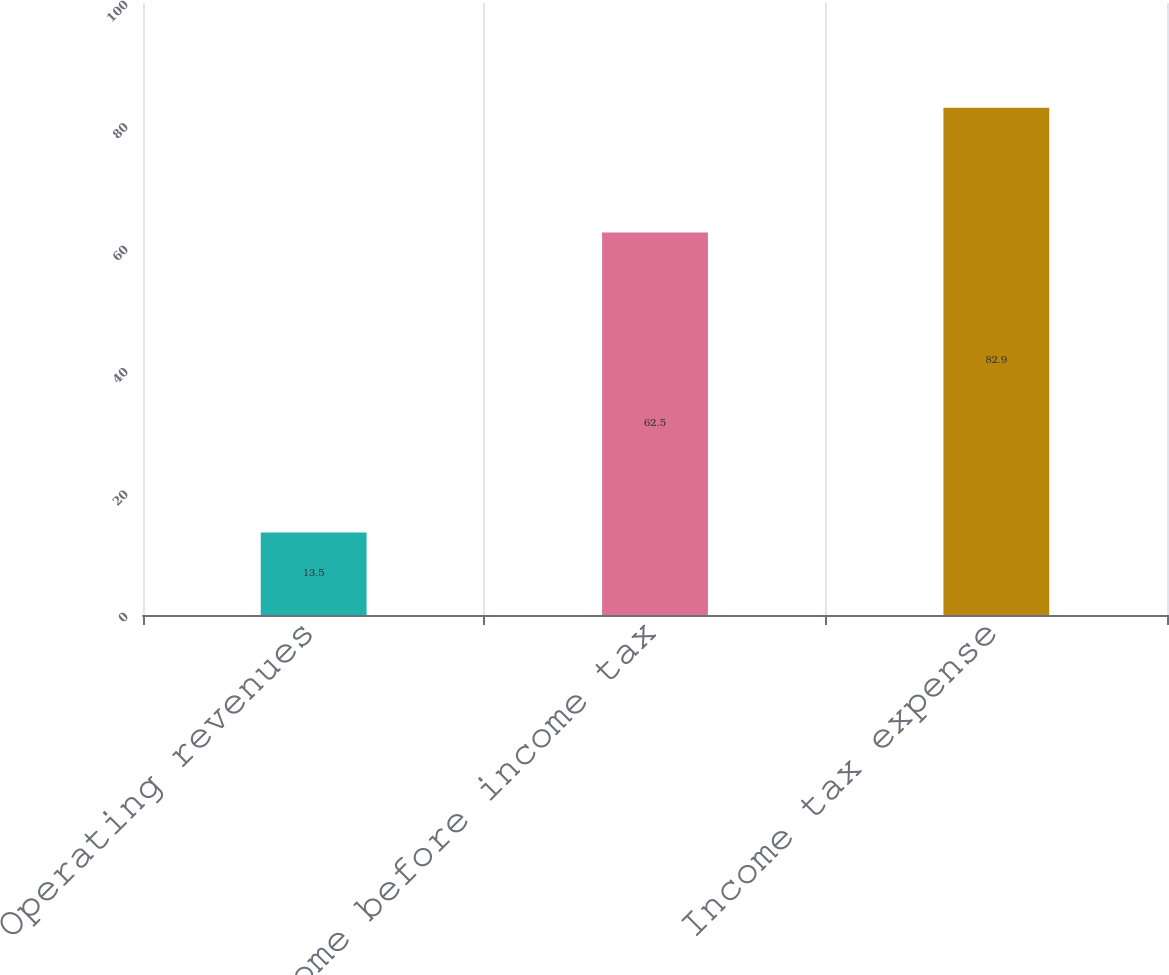Convert chart to OTSL. <chart><loc_0><loc_0><loc_500><loc_500><bar_chart><fcel>Operating revenues<fcel>Income before income tax<fcel>Income tax expense<nl><fcel>13.5<fcel>62.5<fcel>82.9<nl></chart> 